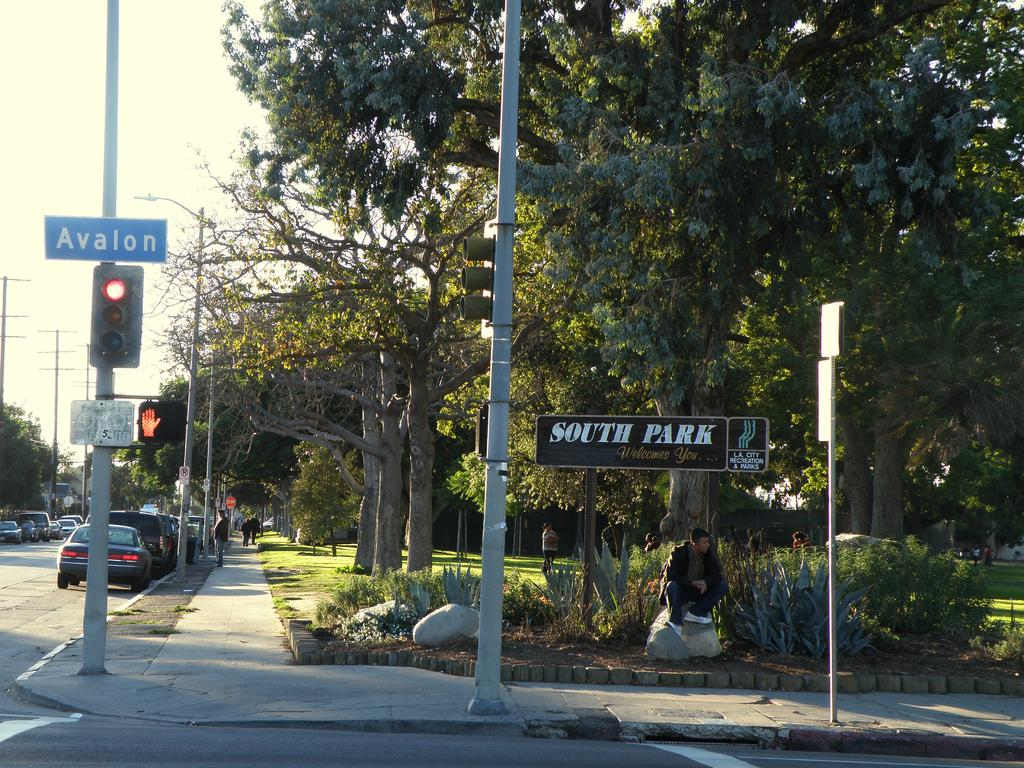<image>
Relay a brief, clear account of the picture shown. A man sitting on a boulder beneath a sign that says South Park. 